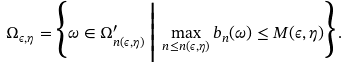Convert formula to latex. <formula><loc_0><loc_0><loc_500><loc_500>\Omega _ { \epsilon , \eta } = \Big \{ \omega \in \Omega ^ { \prime } _ { n ( \epsilon , \eta ) } \, \Big | \, \max _ { n \leq n ( \epsilon , \eta ) } b _ { n } ( \omega ) \leq M ( \epsilon , \eta ) \Big \} \, .</formula> 